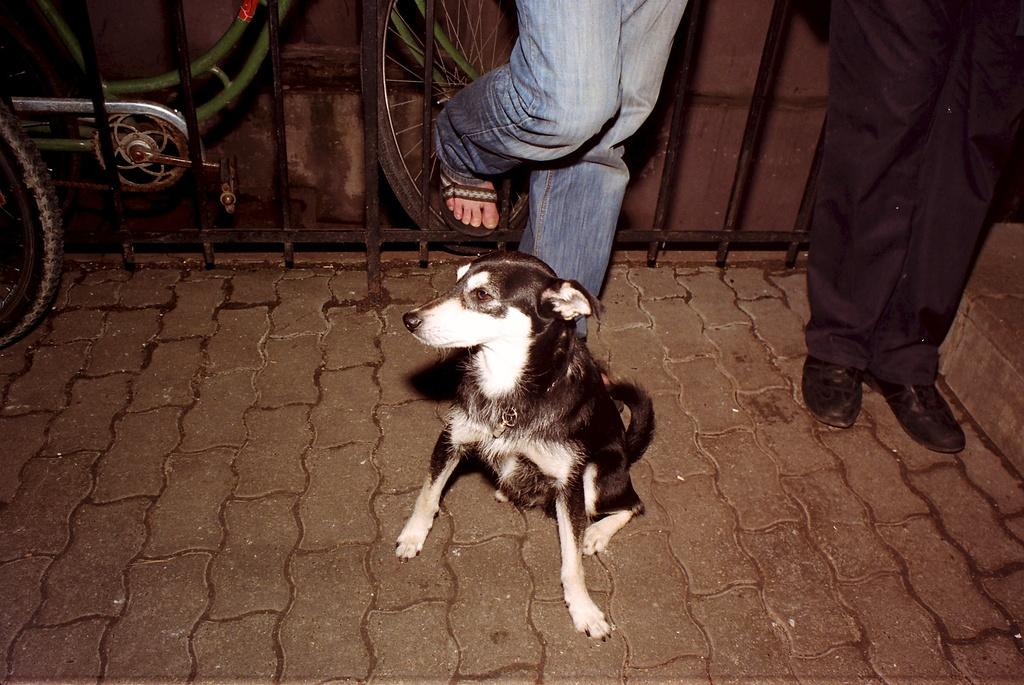What animal can be seen in the image? There is a dog in the image. Where is the dog located? The dog is on the floor. What else can be seen in the background of the image? There are two people standing and an iron railing in the background. What mode of transportation is parked in the image? Cycles are parked in the image. What type of picture is hanging on the wall in the image? There is no picture hanging on the wall in the image; it only features a dog, people, iron railing, and parked cycles. What kind of music can be heard playing in the background of the image? There is no music present in the image; it is a still photograph. 